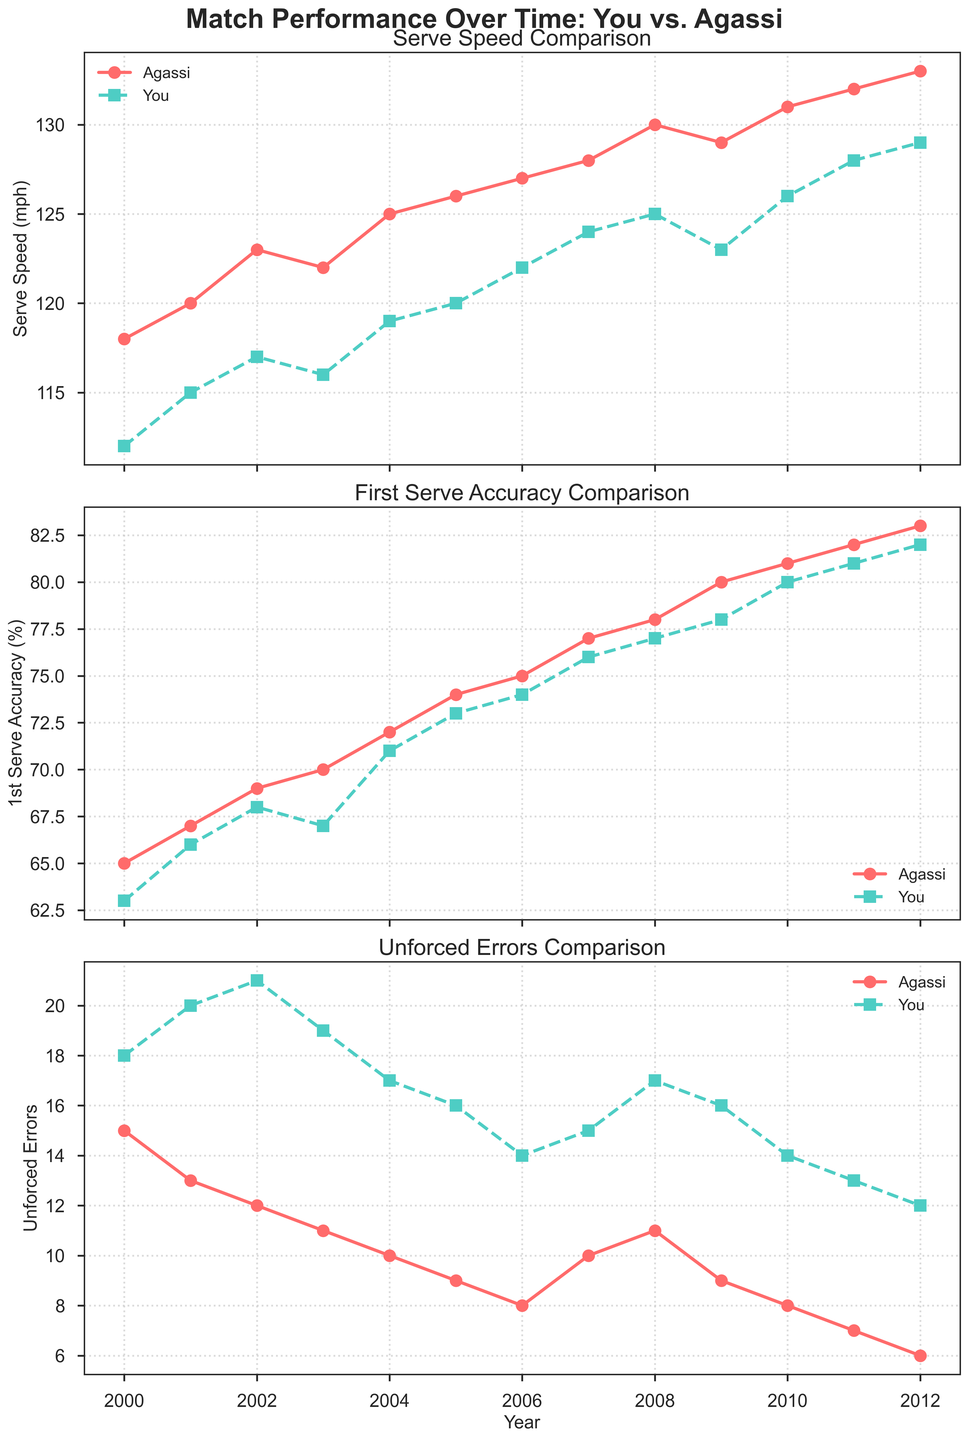What is the title of the first subplot? The title is located at the top of the first subplot. It reads "Serve Speed Comparison".
Answer: Serve Speed Comparison How many years are shown in the figure? The x-axis of each subplot represents years. Counting the data points, we see there are 13 years from 2000 to 2012.
Answer: 13 Which player had a higher serve speed in 2005? By looking at the 2005 data points on the first subplot, Agassi's line (red) is at 126 mph while your line (green) is at 120 mph.
Answer: Agassi What was your first serve accuracy in 2010? On the second subplot titled "First Serve Accuracy Comparison", locate 2010 on the x-axis. The green line (representing your serve accuracy) is at 80%.
Answer: 80% How did Agassi's unforced errors change from 2004 to 2006? On the third subplot titled "Unforced Errors Comparison", find the points for 2004 and 2006. Agassi's errors decreased from 10 to 8.
Answer: Decreased What is the difference in serve speed between you and Agassi in 2009? Check the serve speed values for 2009 in the first subplot. Agassi's serve speed is 129 mph and yours is 123 mph. The difference is 129 - 123 = 6 mph.
Answer: 6 mph In which year did you achieve a serve speed equal to Agassi's serve speed in 2002? Check the serve speed in 2002 where Agassi’s is 123 mph. Your serve speeds in subsequent years should match this, which can be seen in 2008 where both are 125 mph.
Answer: 2008 How did your unforced errors change from 2003 to 2011? Locate the data points for 2003 and 2011 on the third subplot. Your errors decreased from 19 to 13.
Answer: Decreased Which year shows the highest first serve accuracy for you? Look at the second subplot and locate the highest point on the green line (representing your serve accuracy). This is in 2012 with an accuracy of 82%.
Answer: 2012 Compare Agassi’s first serve accuracy in 2005 and 2010. Which year was higher? For both years, refer to the second subplot. Agassi's first serve accuracy in 2005 is 74%, while in 2010 it is 81%.
Answer: 2010 